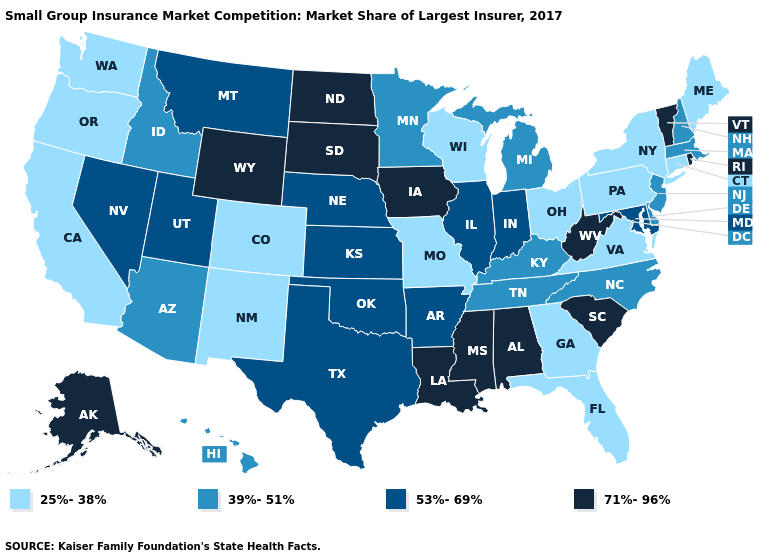Which states have the lowest value in the USA?
Write a very short answer. California, Colorado, Connecticut, Florida, Georgia, Maine, Missouri, New Mexico, New York, Ohio, Oregon, Pennsylvania, Virginia, Washington, Wisconsin. Among the states that border Utah , does Arizona have the lowest value?
Be succinct. No. What is the value of Wisconsin?
Quick response, please. 25%-38%. What is the value of Michigan?
Be succinct. 39%-51%. What is the value of Rhode Island?
Quick response, please. 71%-96%. What is the value of Alabama?
Give a very brief answer. 71%-96%. Among the states that border Maine , which have the highest value?
Keep it brief. New Hampshire. Does Wyoming have the highest value in the West?
Be succinct. Yes. Name the states that have a value in the range 71%-96%?
Write a very short answer. Alabama, Alaska, Iowa, Louisiana, Mississippi, North Dakota, Rhode Island, South Carolina, South Dakota, Vermont, West Virginia, Wyoming. What is the value of Washington?
Answer briefly. 25%-38%. What is the value of Montana?
Be succinct. 53%-69%. Does Delaware have a higher value than Missouri?
Short answer required. Yes. Name the states that have a value in the range 39%-51%?
Concise answer only. Arizona, Delaware, Hawaii, Idaho, Kentucky, Massachusetts, Michigan, Minnesota, New Hampshire, New Jersey, North Carolina, Tennessee. What is the value of Texas?
Keep it brief. 53%-69%. What is the value of Virginia?
Answer briefly. 25%-38%. 